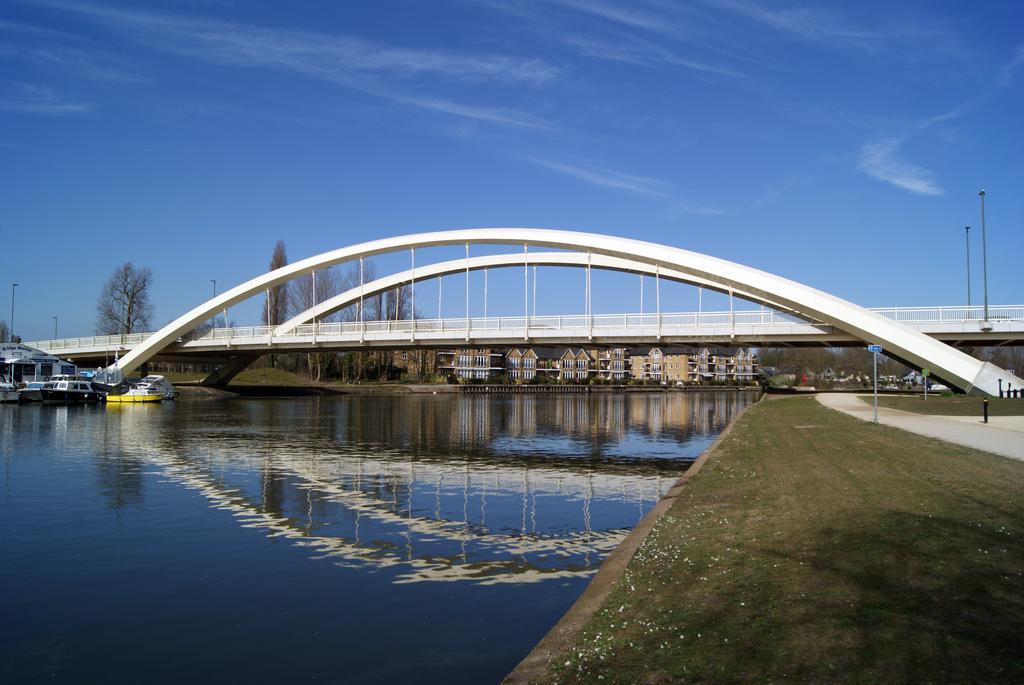Describe this image in one or two sentences. We can see water and grass. On the background we can see boats,bridge,buildings,trees,poles and sky. 